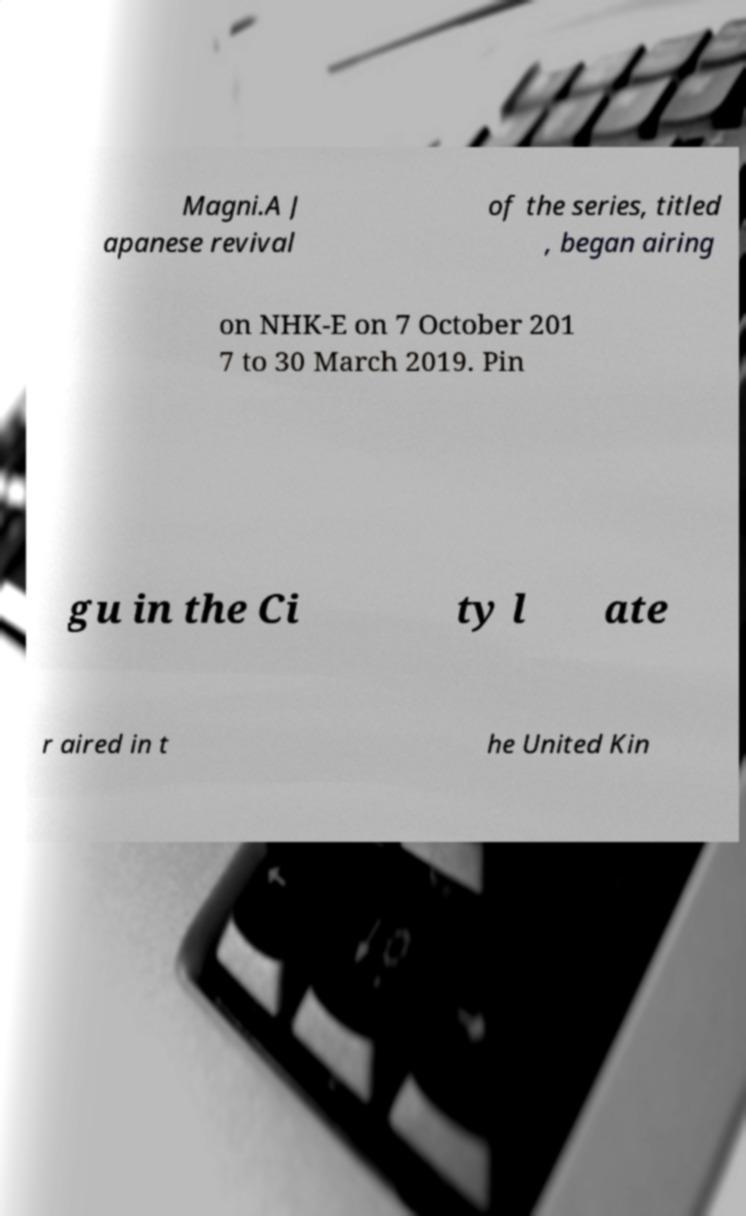Can you accurately transcribe the text from the provided image for me? Magni.A J apanese revival of the series, titled , began airing on NHK-E on 7 October 201 7 to 30 March 2019. Pin gu in the Ci ty l ate r aired in t he United Kin 